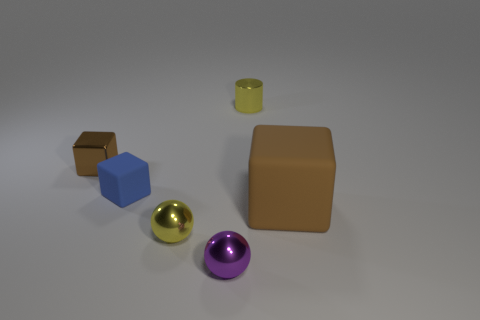What can the materials of the objects in the image suggest about their potential uses? The materials of the objects suggest different functionalities. The brown rubber block might be a stand-in for items such as erasers or gasket materials due to its appearance of softness and malleability. The metal objects, like the tiny yellow cylinder and the spheres, have a sheen indicative of hard, durable materials suitable for bearings or decorative elements. The blue cube's matte finish doesn't reflect light, suggesting a possible utilitarian use where glare or reflection should be avoided.  Could you infer anything about the creator's intentions with the arrangement of these objects? The creator may have arranged these objects to explore contrast and composition: the difference in texture, color, and material between the objects provides visual interest. The arrangement can also be an exercise in studying light interaction with different surfaces or a simple demonstration of shape recognition, with each object representing a primary geometric form. 